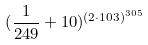Convert formula to latex. <formula><loc_0><loc_0><loc_500><loc_500>( \frac { 1 } { 2 4 9 } + 1 0 ) ^ { ( 2 \cdot 1 0 3 ) ^ { 3 0 5 } }</formula> 